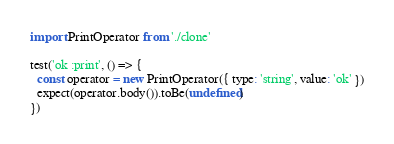<code> <loc_0><loc_0><loc_500><loc_500><_JavaScript_>import PrintOperator from './clone'

test('ok :print', () => {
  const operator = new PrintOperator({ type: 'string', value: 'ok' })
  expect(operator.body()).toBe(undefined)
})</code> 